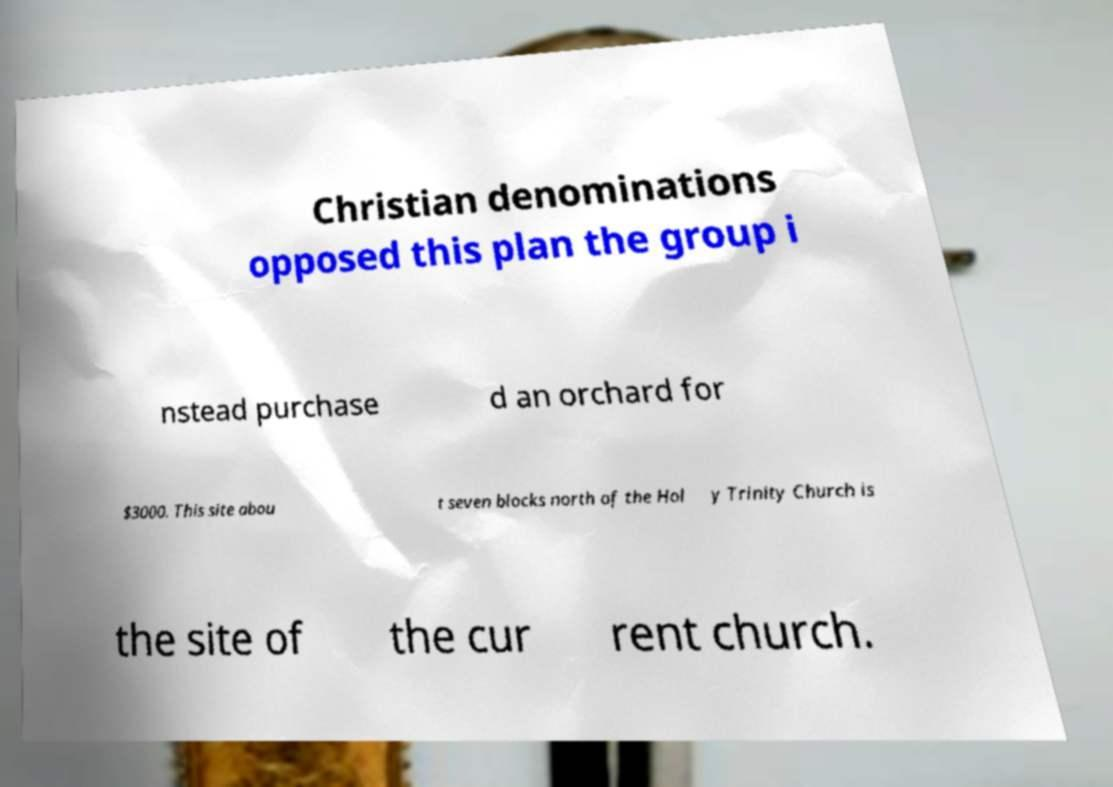I need the written content from this picture converted into text. Can you do that? Christian denominations opposed this plan the group i nstead purchase d an orchard for $3000. This site abou t seven blocks north of the Hol y Trinity Church is the site of the cur rent church. 